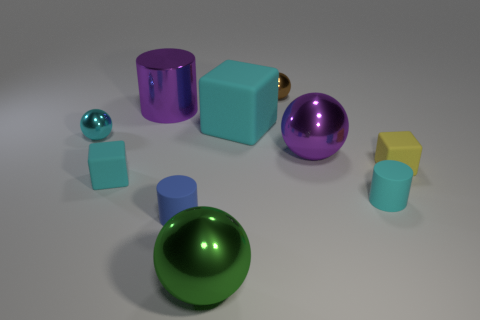How many cyan cubes must be subtracted to get 1 cyan cubes? 1 Subtract all tiny cyan rubber blocks. How many blocks are left? 2 Subtract all cubes. How many objects are left? 7 Subtract 3 cubes. How many cubes are left? 0 Subtract 1 yellow cubes. How many objects are left? 9 Subtract all red spheres. Subtract all blue cubes. How many spheres are left? 4 Subtract all red balls. How many yellow cylinders are left? 0 Subtract all big green spheres. Subtract all large objects. How many objects are left? 5 Add 1 tiny blue cylinders. How many tiny blue cylinders are left? 2 Add 8 small rubber cylinders. How many small rubber cylinders exist? 10 